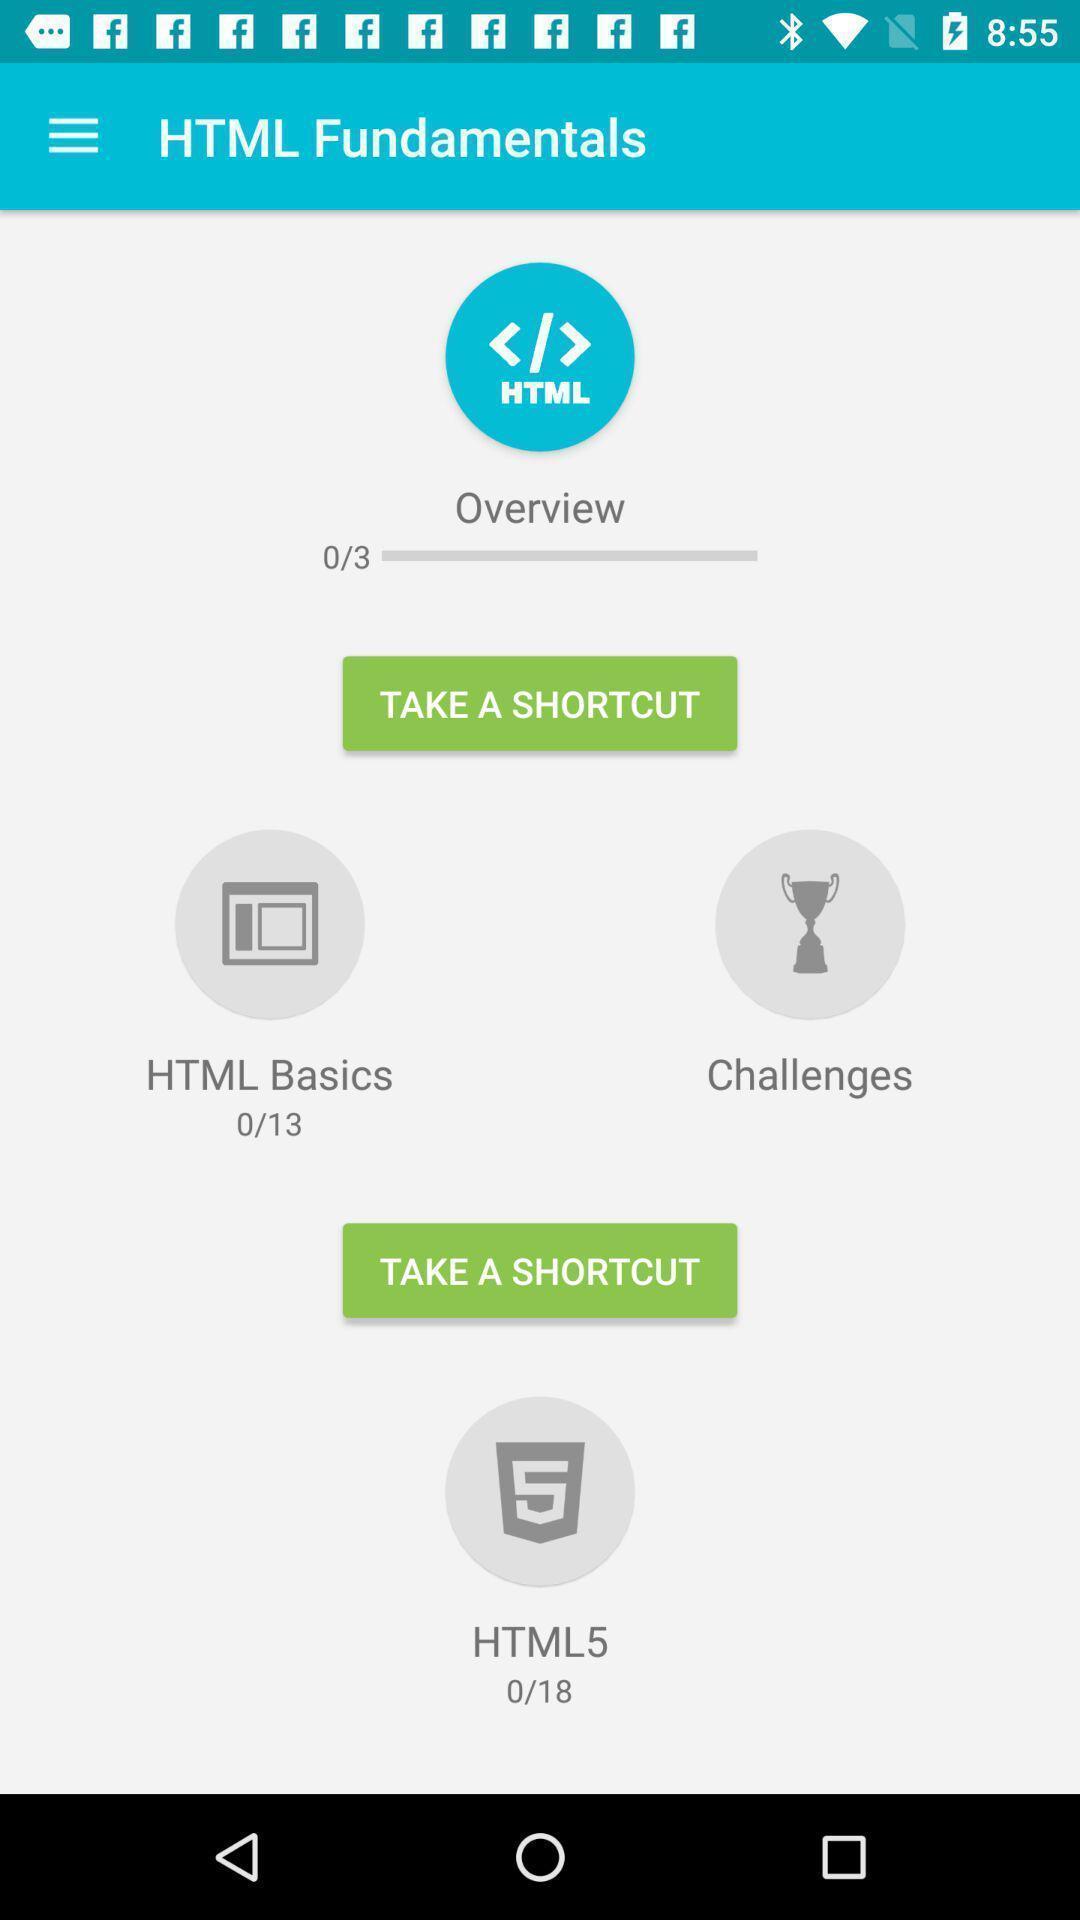Summarize the main components in this picture. Screen showing page of an learning application. 